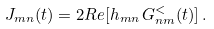<formula> <loc_0><loc_0><loc_500><loc_500>J _ { m n } ( t ) = 2 R e [ h _ { m n } \, G ^ { < } _ { n m } ( t ) ] \, .</formula> 